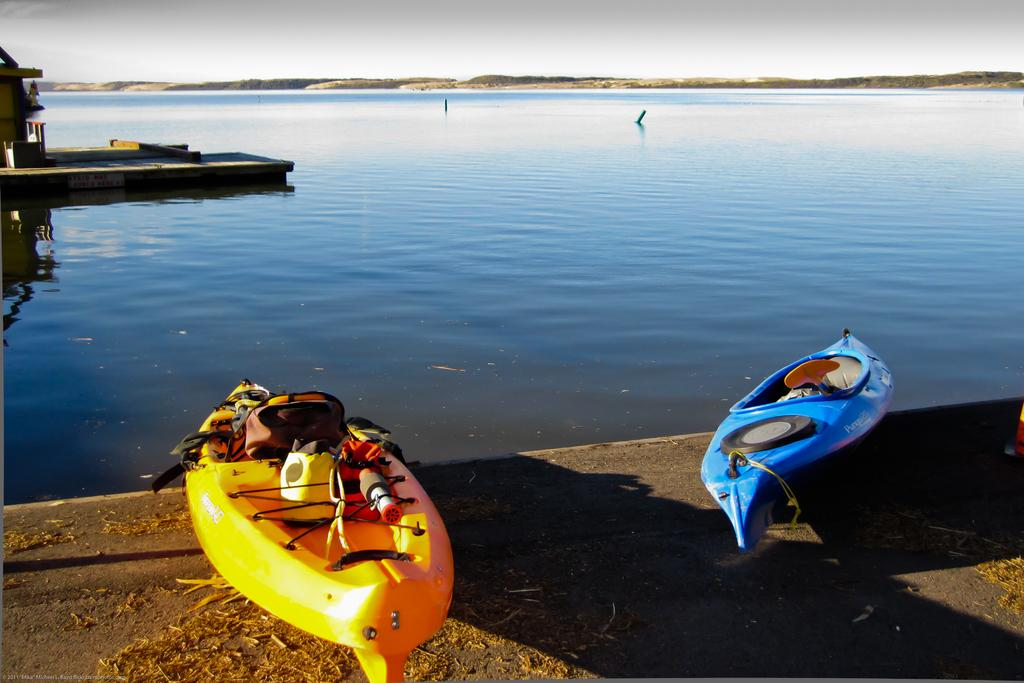What can be seen in the image related to water transportation? There are two boats in the image. How can the boats be distinguished from each other? The boats are in different colors. What body of water are the boats located in? There is a lake in the middle of the image. What is visible at the top of the image? The sky is visible at the top of the image. How many birds are perched on the yoke in the image? There is no yoke or birds present in the image. What type of glass is used to make the boats in the image? The boats are not made of glass; they are likely made of materials such as wood or fiberglass. 